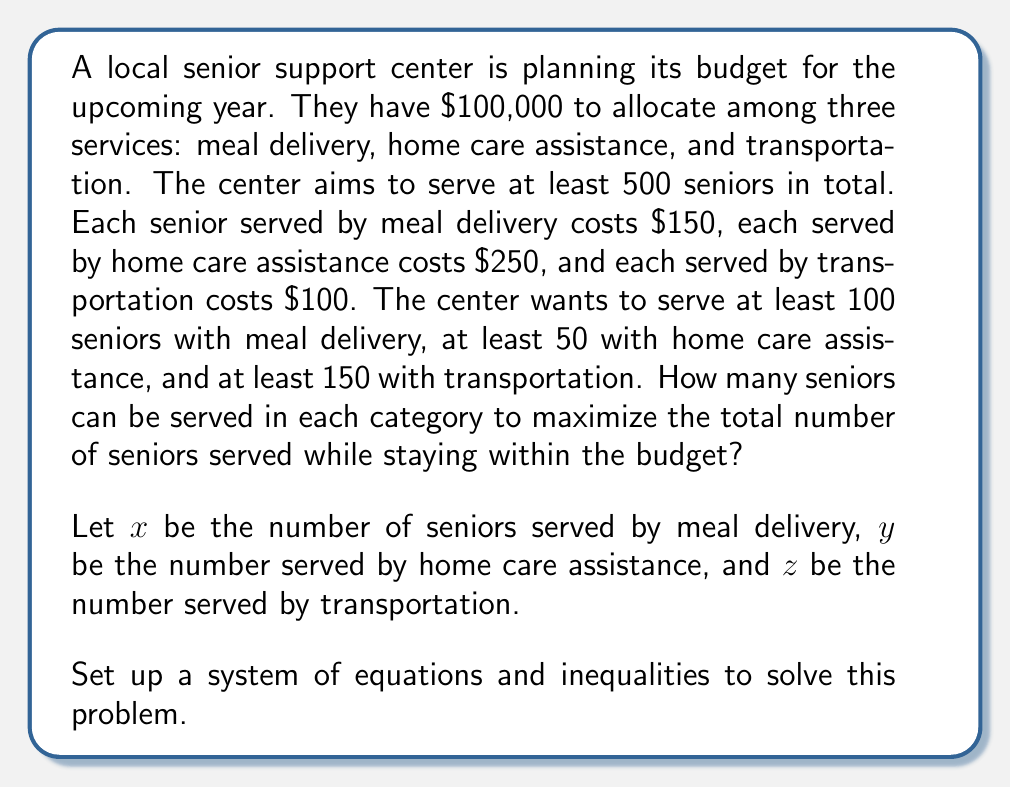Could you help me with this problem? Let's approach this step-by-step:

1) First, we need to set up our constraints:

   Budget constraint: $150x + 250y + 100z \leq 100000$
   Minimum total seniors: $x + y + z \geq 500$
   Minimum meal delivery: $x \geq 100$
   Minimum home care: $y \geq 50$
   Minimum transportation: $z \geq 150$

2) Our objective is to maximize $x + y + z$

3) This is a linear programming problem. We can solve it using the simplex method, but for this problem, we can use reasoning to find the optimal solution.

4) Given the costs per senior for each service, transportation is the cheapest way to serve more seniors. So, we should maximize $z$ after meeting all other constraints.

5) Let's start by meeting the minimum requirements:
   $x = 100$, $y = 50$, $z = 150$

6) This uses up: $100(150) + 50(250) + 150(100) = 15000 + 12500 + 15000 = 42500$ of the budget

7) We have $100000 - 42500 = 57500$ left in the budget

8) We can use this entirely on transportation, which costs $100 per senior

9) Additional seniors served by transportation: $57500 / 100 = 575$

10) So, the final allocation is:
    $x = 100$ (meal delivery)
    $y = 50$ (home care)
    $z = 150 + 575 = 725$ (transportation)

11) Total seniors served: $100 + 50 + 725 = 875$

We can verify that this satisfies all constraints:
- Budget: $150(100) + 250(50) + 100(725) = 15000 + 12500 + 72500 = 100000$
- Total seniors: $875 > 500$
- Minimum requirements for each service are met
Answer: The optimal allocation to maximize the number of seniors served is:
Meal delivery: 100 seniors
Home care assistance: 50 seniors
Transportation: 725 seniors
Total seniors served: 875 